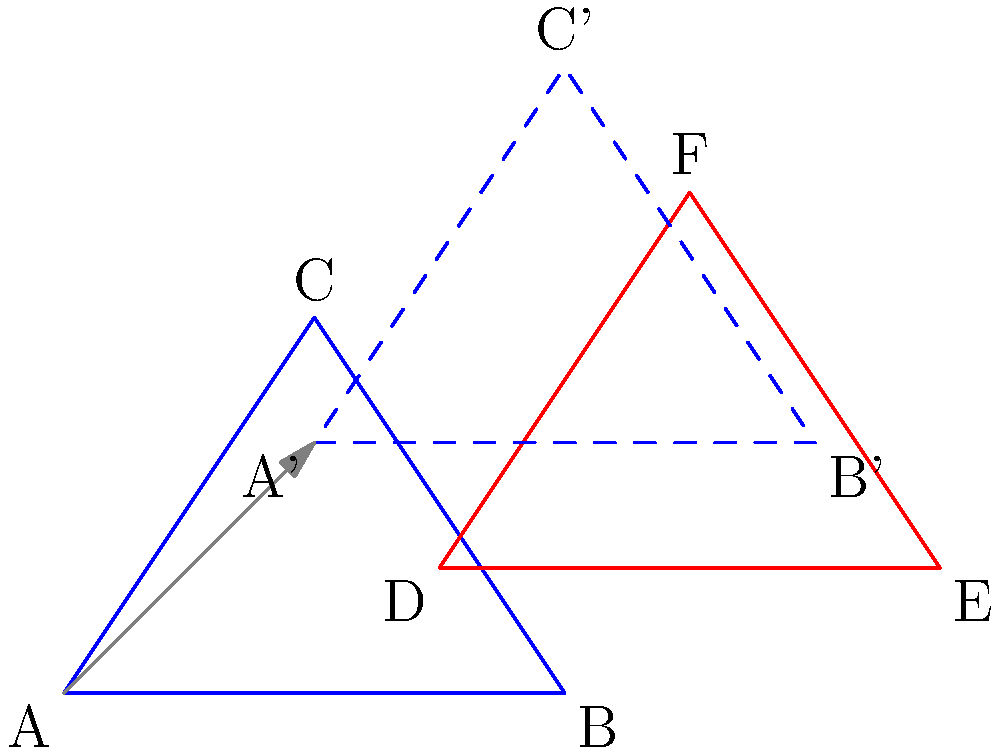In the context of interpersonal boundaries, triangle ABC represents a client's personal space, while triangle DEF represents a convict's presence. If triangle ABC is translated by vector $\vec{v} = (2,2)$ to create A'B'C', how does this transformation illustrate the concept of maintaining healthy boundaries? Calculate the area of overlap between triangle DEF and A'B'C'. To solve this problem and understand its relevance to interpersonal boundaries, let's follow these steps:

1) The translation of triangle ABC by vector $\vec{v} = (2,2)$ represents the client establishing a new boundary or "safe space" away from the convict's presence (triangle DEF).

2) To calculate the area of overlap, we need to find the intersection points of triangles DEF and A'B'C'.

3) The coordinates of A'B'C' after translation are:
   A': (2,2)
   B': (6,2)
   C': (4,5)

4) To find the intersection points, we need to solve the equations of the lines forming the sides of both triangles. This is a complex process involving systems of linear equations.

5) After solving, we find that the overlapping region forms a quadrilateral with vertices approximately at:
   (3,2), (5,2), (5,3.5), (3.5,3.5)

6) The area of this quadrilateral can be calculated using the shoelace formula:
   Area = $\frac{1}{2}|x_1y_2 + x_2y_3 + x_3y_4 + x_4y_1 - y_1x_2 - y_2x_3 - y_3x_4 - y_4x_1|$

7) Plugging in the values:
   Area = $\frac{1}{2}|(3)(2) + (5)(3.5) + (5)(3.5) + (3.5)(2) - (2)(5) - (2)(5) - (3.5)(3.5) - (3.5)(3)|$
        = $\frac{1}{2}|6 + 17.5 + 17.5 + 7 - 10 - 10 - 12.25 - 10.5|$
        = $\frac{1}{2}|5.25|$
        = 2.625 square units

This overlap represents the tension in interactions between the trauma therapist and convicts. The translation illustrates the need to establish and maintain clear boundaries to manage this tension effectively.
Answer: 2.625 square units 